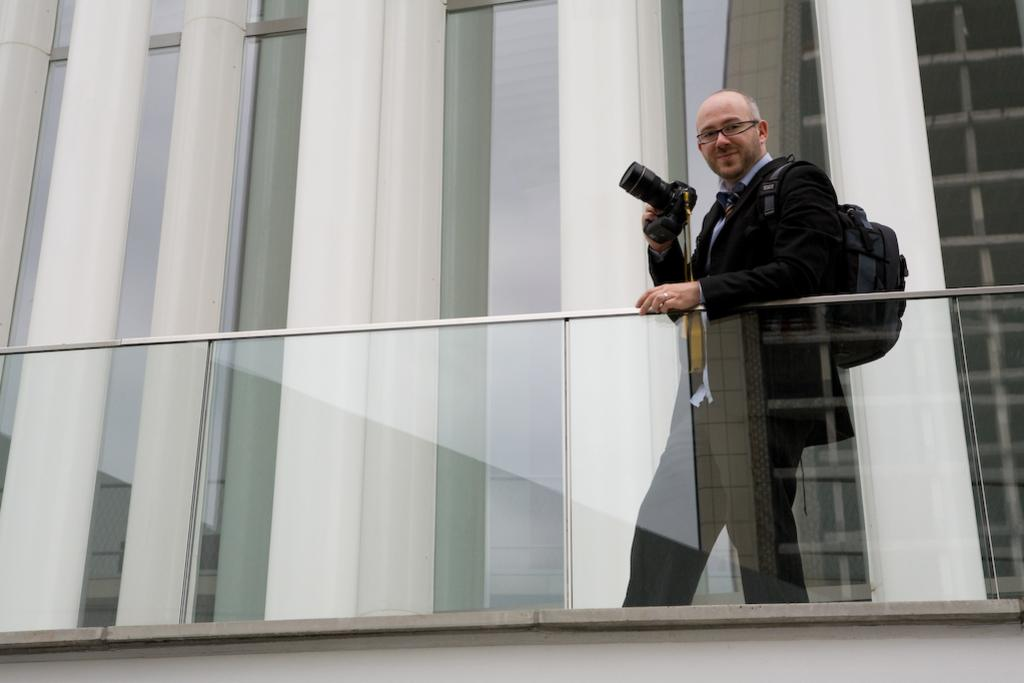What is the person in the image doing? The person is standing in the image and holding a camera. What might the person be planning to do with the camera? The person might be planning to take a photo or record a video. What is the glass wall in the image used for? The glass wall in the image is likely used for separating spaces or providing a barrier. What can be seen in the background of the image? There is a building in the background of the image. What type of string is being used by the cook in the image? There is no cook or string present in the image; it features a person holding a camera and a glass wall with a building in the background. 